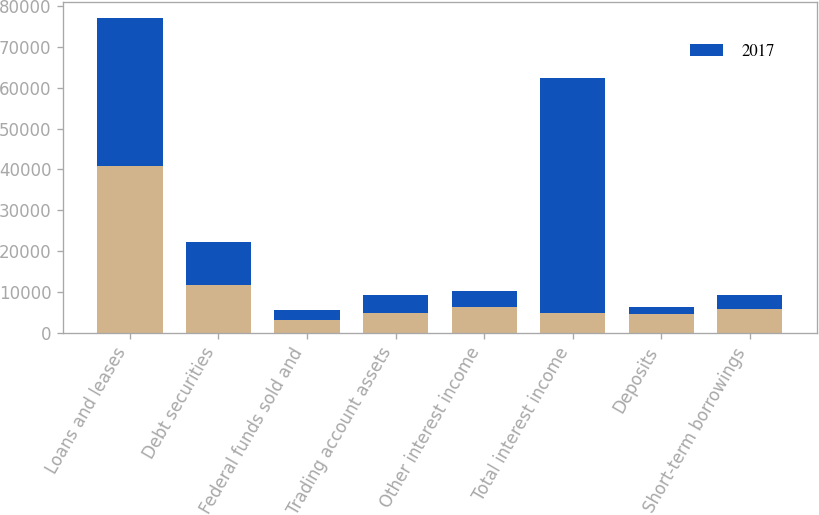Convert chart. <chart><loc_0><loc_0><loc_500><loc_500><stacked_bar_chart><ecel><fcel>Loans and leases<fcel>Debt securities<fcel>Federal funds sold and<fcel>Trading account assets<fcel>Other interest income<fcel>Total interest income<fcel>Deposits<fcel>Short-term borrowings<nl><fcel>nan<fcel>40811<fcel>11724<fcel>3176<fcel>4811<fcel>6247<fcel>4811<fcel>4495<fcel>5839<nl><fcel>2017<fcel>36221<fcel>10471<fcel>2390<fcel>4474<fcel>4023<fcel>57579<fcel>1931<fcel>3538<nl></chart> 